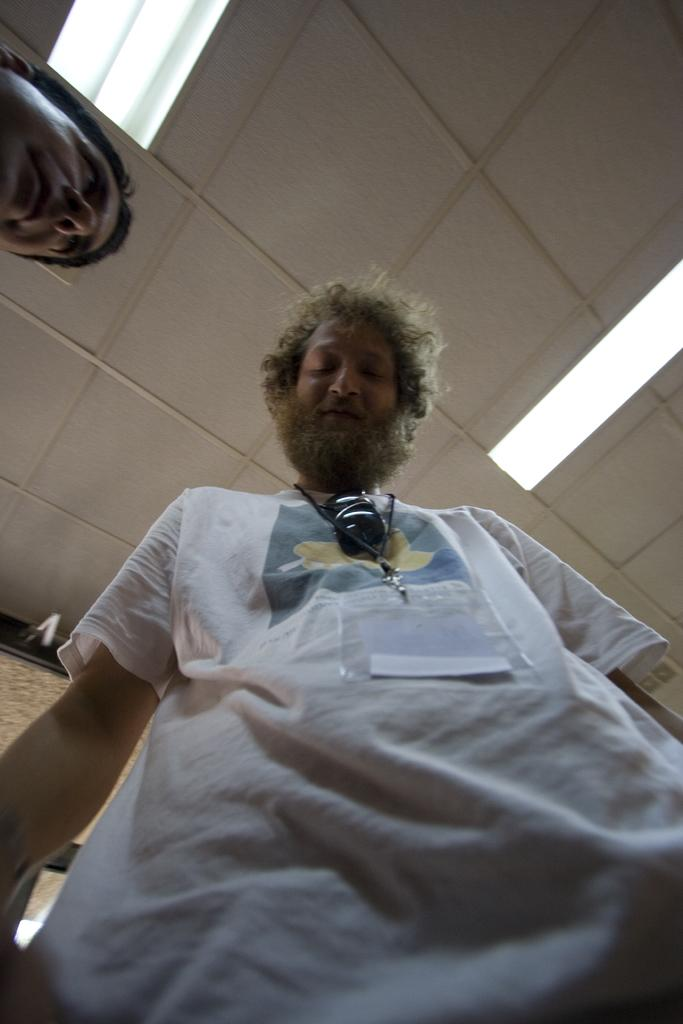What is the main subject of the image? There is a person standing in the image. Can you describe the person's appearance? The person is wearing clothes. What is above the person in the image? There is a ceiling at the top of the image. What can be seen on the ceiling? The ceiling contains lights. Is there any other person visible in the image? Yes, there is another person's head visible in the top left of the image. What type of wool is being used to make the trucks in the image? There are no trucks present in the image, and therefore no wool is being used to make them. How many beds can be seen in the image? There are no beds visible in the image. 